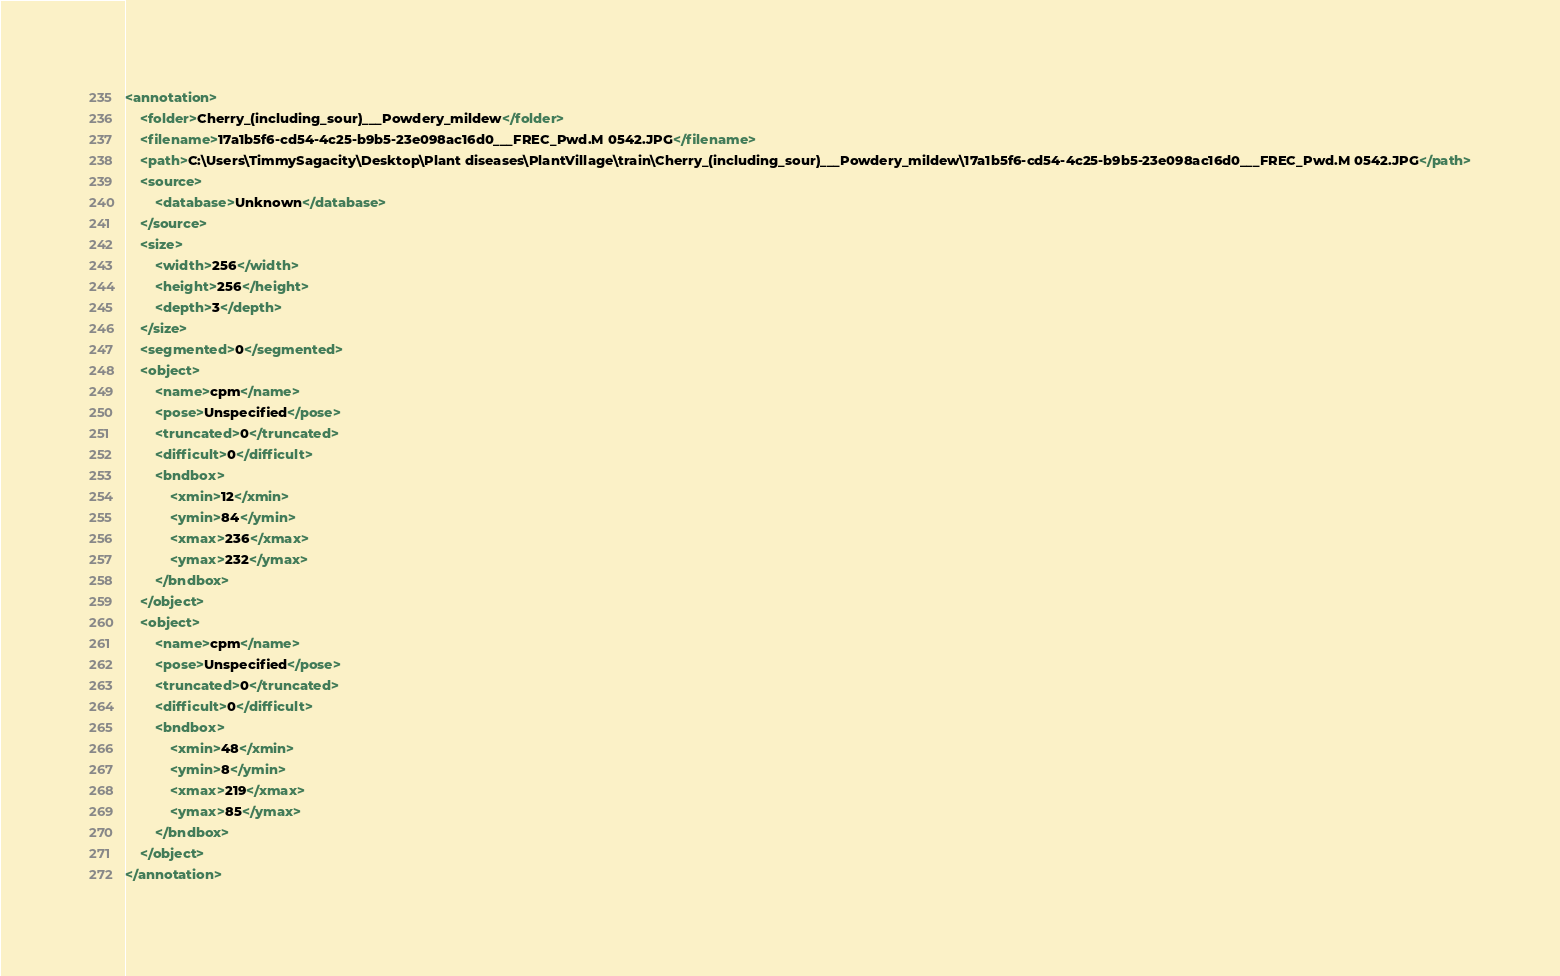Convert code to text. <code><loc_0><loc_0><loc_500><loc_500><_XML_><annotation>
	<folder>Cherry_(including_sour)___Powdery_mildew</folder>
	<filename>17a1b5f6-cd54-4c25-b9b5-23e098ac16d0___FREC_Pwd.M 0542.JPG</filename>
	<path>C:\Users\TimmySagacity\Desktop\Plant diseases\PlantVillage\train\Cherry_(including_sour)___Powdery_mildew\17a1b5f6-cd54-4c25-b9b5-23e098ac16d0___FREC_Pwd.M 0542.JPG</path>
	<source>
		<database>Unknown</database>
	</source>
	<size>
		<width>256</width>
		<height>256</height>
		<depth>3</depth>
	</size>
	<segmented>0</segmented>
	<object>
		<name>cpm</name>
		<pose>Unspecified</pose>
		<truncated>0</truncated>
		<difficult>0</difficult>
		<bndbox>
			<xmin>12</xmin>
			<ymin>84</ymin>
			<xmax>236</xmax>
			<ymax>232</ymax>
		</bndbox>
	</object>
	<object>
		<name>cpm</name>
		<pose>Unspecified</pose>
		<truncated>0</truncated>
		<difficult>0</difficult>
		<bndbox>
			<xmin>48</xmin>
			<ymin>8</ymin>
			<xmax>219</xmax>
			<ymax>85</ymax>
		</bndbox>
	</object>
</annotation>
</code> 